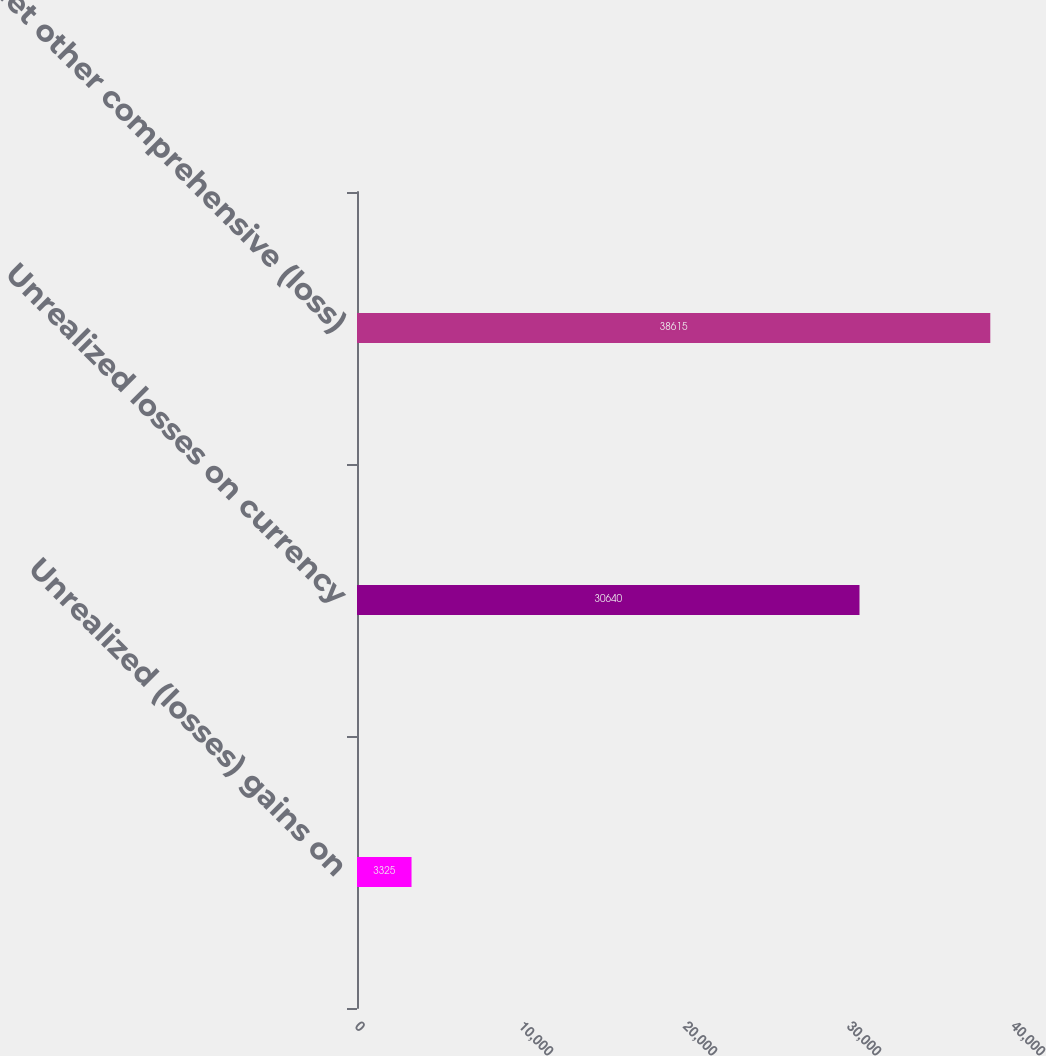Convert chart. <chart><loc_0><loc_0><loc_500><loc_500><bar_chart><fcel>Unrealized (losses) gains on<fcel>Unrealized losses on currency<fcel>Net other comprehensive (loss)<nl><fcel>3325<fcel>30640<fcel>38615<nl></chart> 